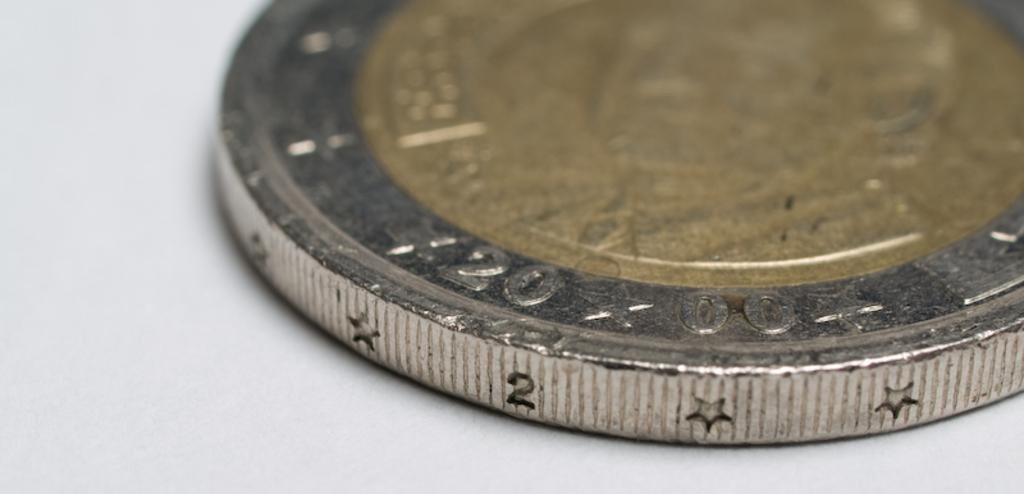<image>
Share a concise interpretation of the image provided. A coin from the year 2000 has stars on its edge. 